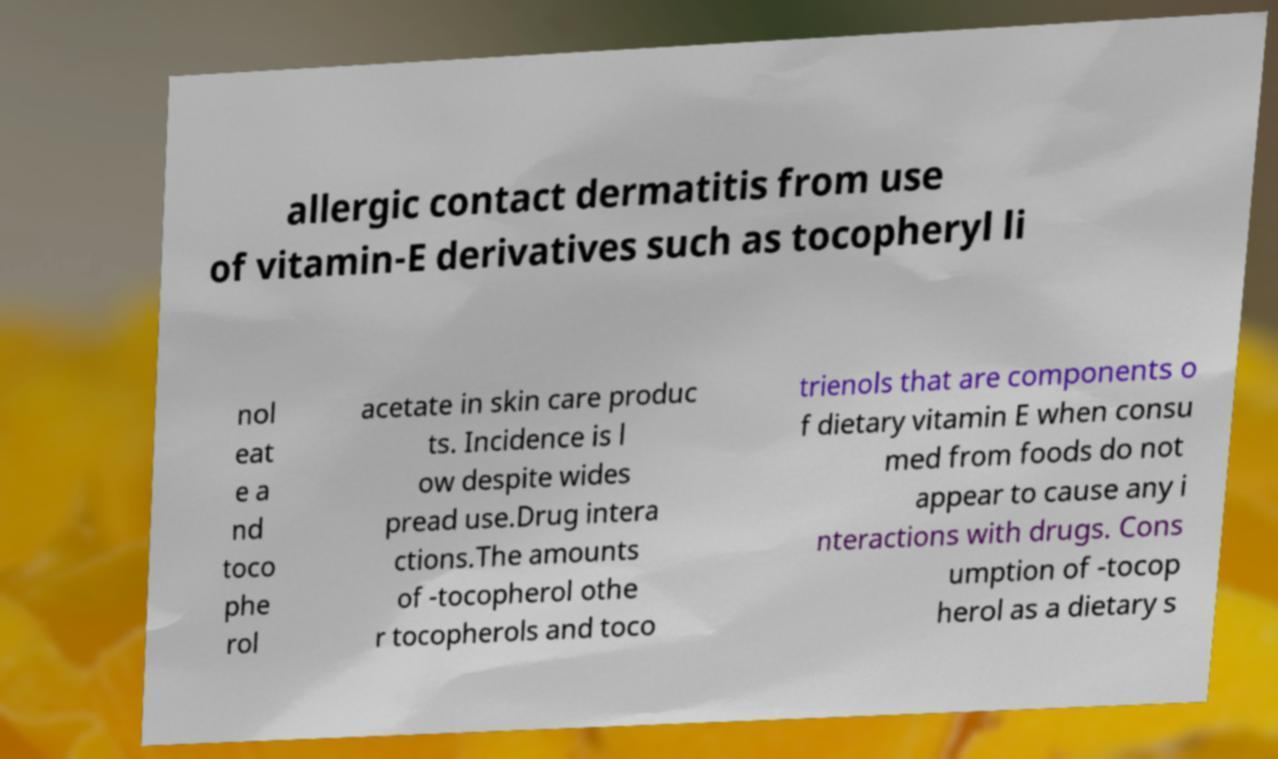For documentation purposes, I need the text within this image transcribed. Could you provide that? allergic contact dermatitis from use of vitamin-E derivatives such as tocopheryl li nol eat e a nd toco phe rol acetate in skin care produc ts. Incidence is l ow despite wides pread use.Drug intera ctions.The amounts of -tocopherol othe r tocopherols and toco trienols that are components o f dietary vitamin E when consu med from foods do not appear to cause any i nteractions with drugs. Cons umption of -tocop herol as a dietary s 